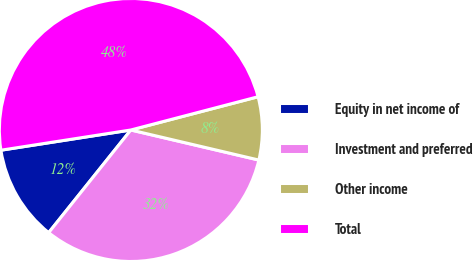<chart> <loc_0><loc_0><loc_500><loc_500><pie_chart><fcel>Equity in net income of<fcel>Investment and preferred<fcel>Other income<fcel>Total<nl><fcel>11.8%<fcel>32.07%<fcel>7.74%<fcel>48.39%<nl></chart> 